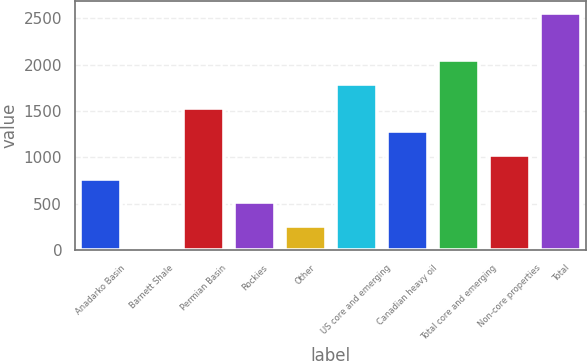<chart> <loc_0><loc_0><loc_500><loc_500><bar_chart><fcel>Anadarko Basin<fcel>Barnett Shale<fcel>Permian Basin<fcel>Rockies<fcel>Other<fcel>US core and emerging<fcel>Canadian heavy oil<fcel>Total core and emerging<fcel>Non-core properties<fcel>Total<nl><fcel>769.96<fcel>1.6<fcel>1538.32<fcel>513.84<fcel>257.72<fcel>1794.44<fcel>1282.2<fcel>2050.56<fcel>1026.08<fcel>2562.8<nl></chart> 